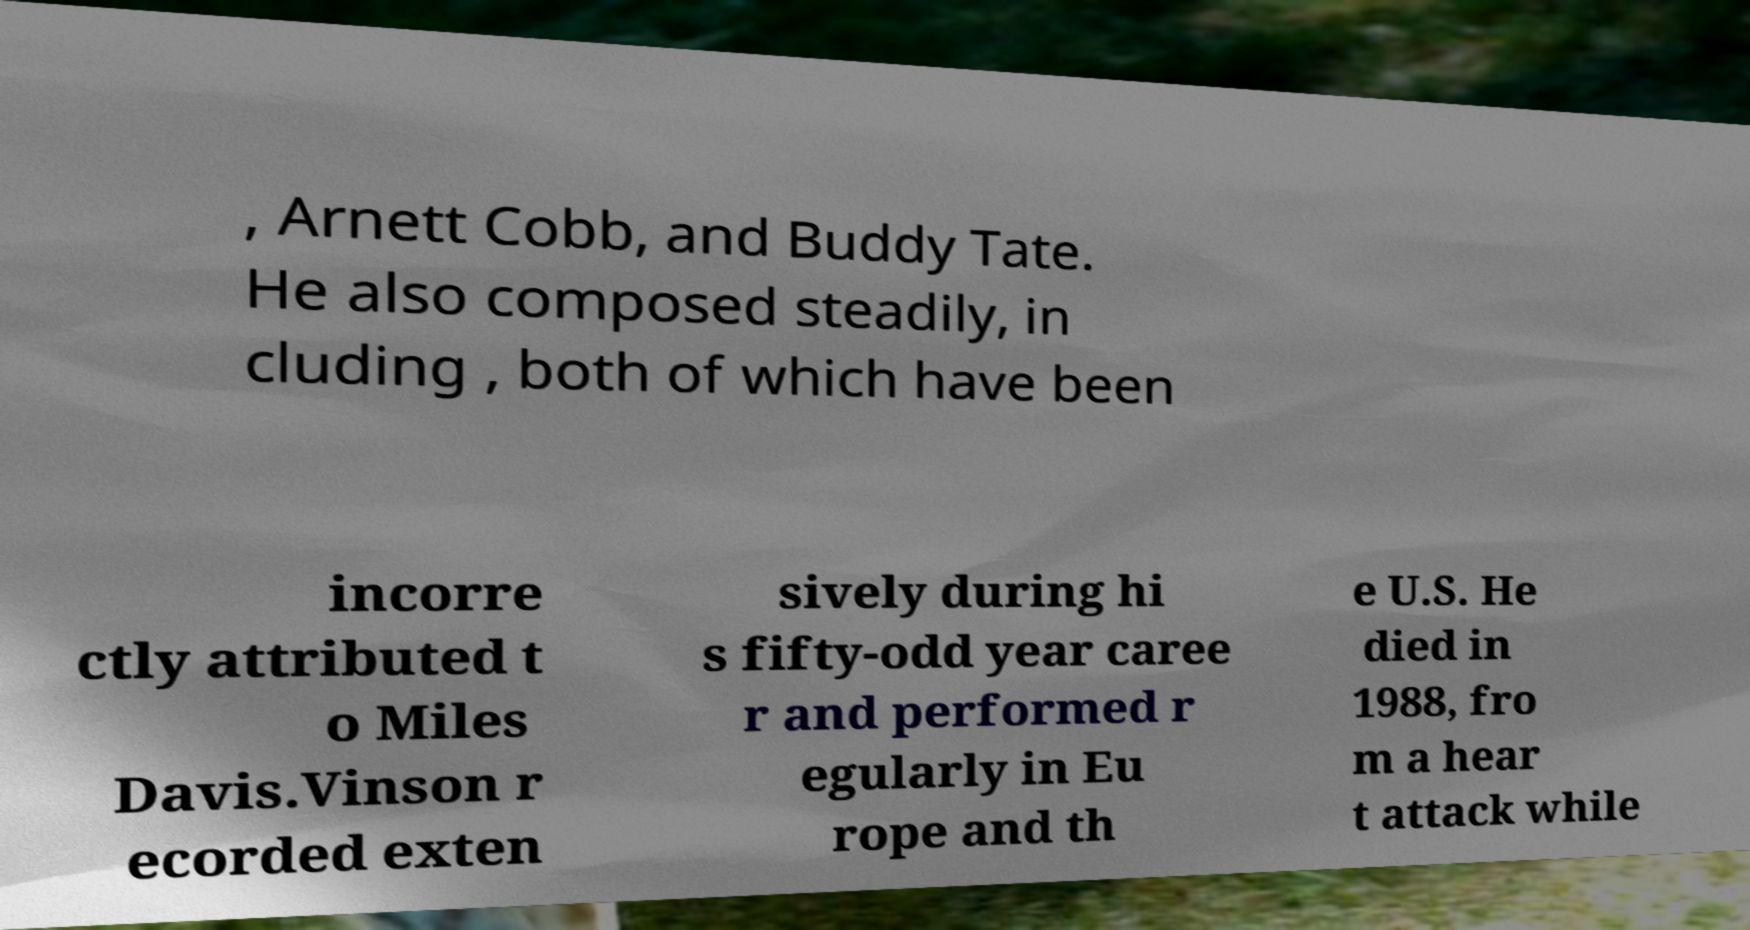Could you assist in decoding the text presented in this image and type it out clearly? , Arnett Cobb, and Buddy Tate. He also composed steadily, in cluding , both of which have been incorre ctly attributed t o Miles Davis.Vinson r ecorded exten sively during hi s fifty-odd year caree r and performed r egularly in Eu rope and th e U.S. He died in 1988, fro m a hear t attack while 